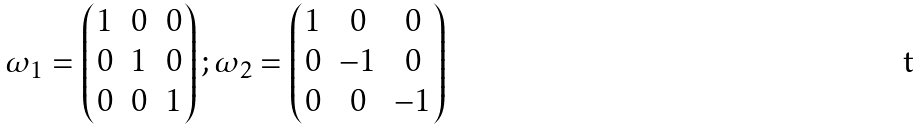<formula> <loc_0><loc_0><loc_500><loc_500>\omega _ { 1 } = \begin{pmatrix} 1 & 0 & 0 \\ 0 & 1 & 0 \\ 0 & 0 & 1 \end{pmatrix} ; \omega _ { 2 } = \begin{pmatrix} 1 & 0 & 0 \\ 0 & - 1 & 0 \\ 0 & 0 & - 1 \end{pmatrix}</formula> 